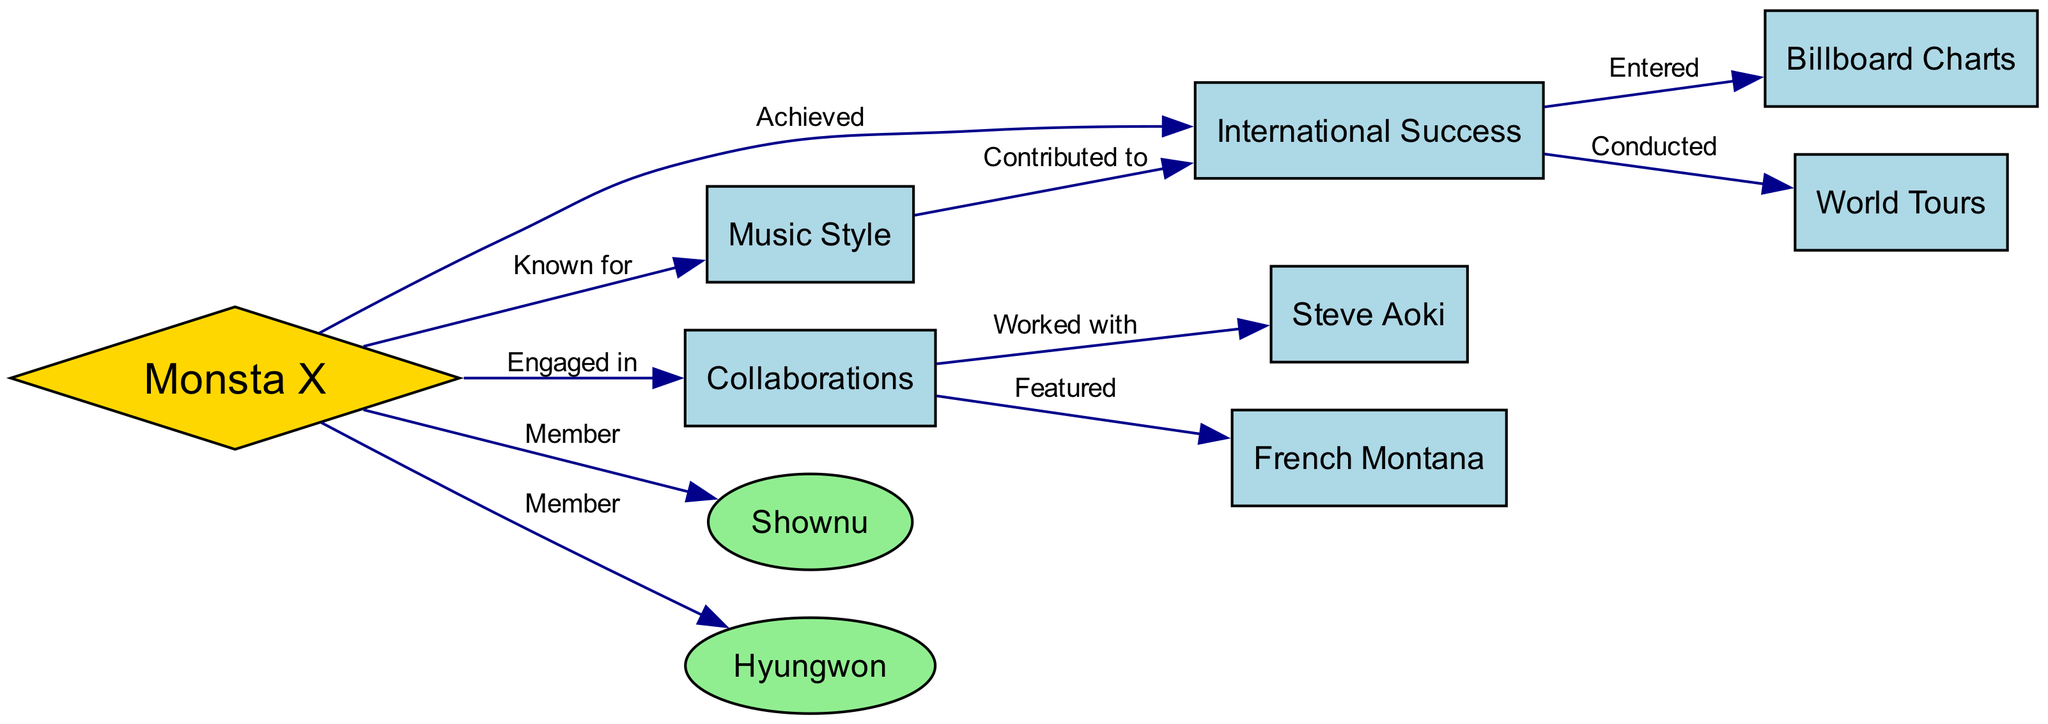What is the main label of the central node in the diagram? The central node is labeled "Monsta X," which indicates it as the main subject of the concept map around which all other information is organized.
Answer: Monsta X How many members are listed in the diagram? There are two members listed: "Shownu" and "Hyungwon," as indicated by their connections to the main node "Monsta X."
Answer: 2 Which node represents the impact on global music charts? The node "Billboard Charts" illustrates the impact of Monsta X's international success on global music metrics, such as entering these charts.
Answer: Billboard Charts What type of relationship exists between "Monsta X" and "International Success"? The diagram shows a relationship labeled "Achieved" connecting "Monsta X" to "International Success," indicating Monsta X has attained this level of success.
Answer: Achieved Which collaborations does Monsta X have according to the diagram? The diagram illustrates "Steve Aoki" and "French Montana" as collaborators, shown by the edges labeled "Worked with" and "Featured," respectively.
Answer: Steve Aoki, French Montana What is the contribution of "Music Style" to "International Success"? The edge labeled "Contributed to" clearly shows that the unique "Music Style" of Monsta X has played a role in achieving "International Success."
Answer: Contributed to How many collaborations are mentioned in the diagram? There are two collaborations noted in the diagram: "Steve Aoki" and "French Montana," as both are connected under the "Collaborations" node.
Answer: 2 What characteristic is Monsta X known for? The node "Music Style" indicates that Monsta X is known for a specific musical genre or approach, highlighting their unique sound in the K-pop industry.
Answer: Music Style What is one activity that Monsta X conducted as part of their international success? The diagram mentions "World Tours," indicating that Monsta X entertained fans globally, contributing to their international presence.
Answer: World Tours 